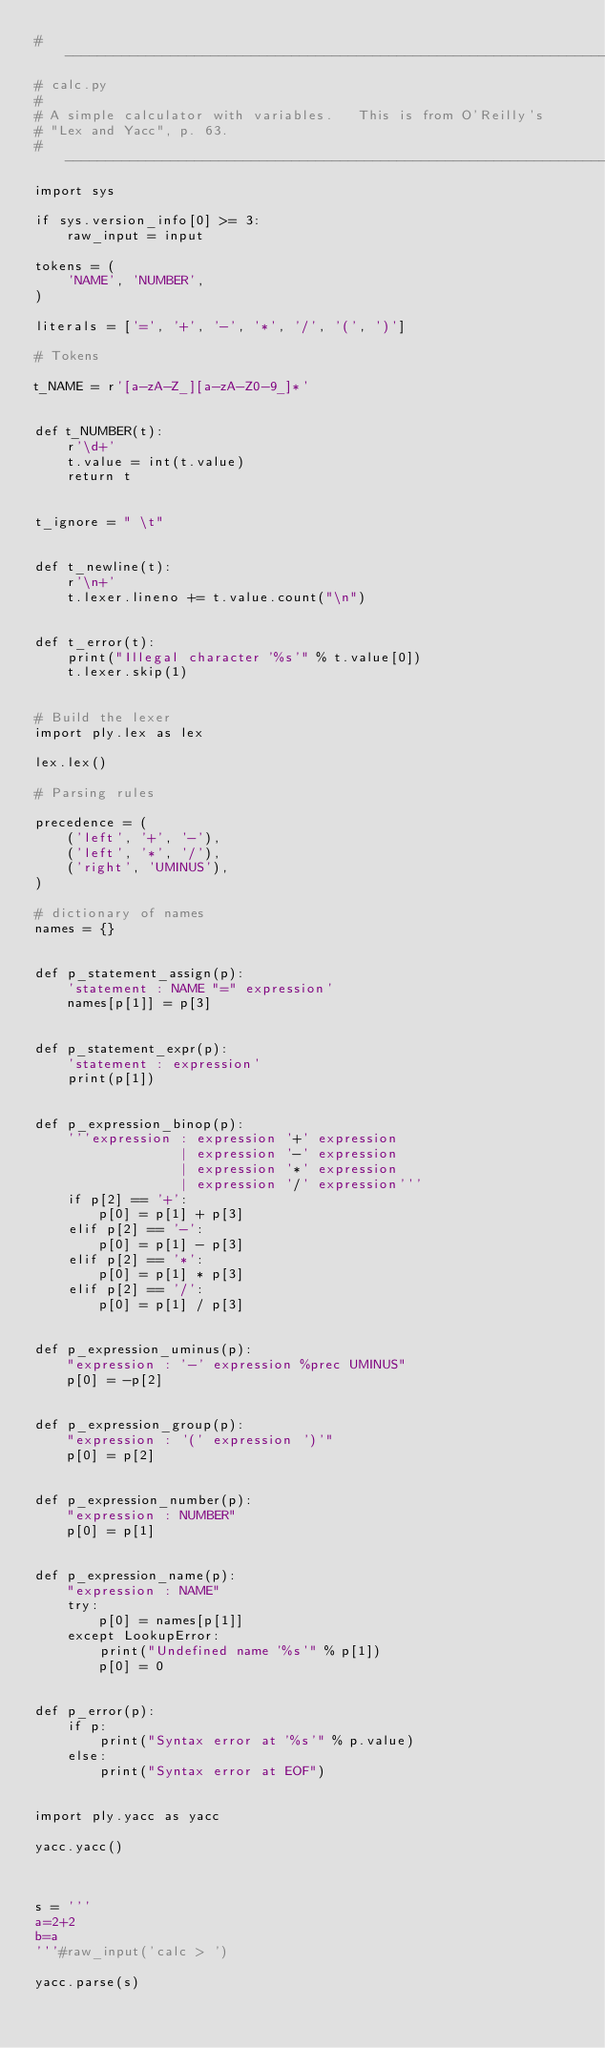<code> <loc_0><loc_0><loc_500><loc_500><_Python_># -----------------------------------------------------------------------------
# calc.py
#
# A simple calculator with variables.   This is from O'Reilly's
# "Lex and Yacc", p. 63.
# -----------------------------------------------------------------------------
import sys

if sys.version_info[0] >= 3:
    raw_input = input

tokens = (
    'NAME', 'NUMBER',
)

literals = ['=', '+', '-', '*', '/', '(', ')']

# Tokens

t_NAME = r'[a-zA-Z_][a-zA-Z0-9_]*'


def t_NUMBER(t):
    r'\d+'
    t.value = int(t.value)
    return t


t_ignore = " \t"


def t_newline(t):
    r'\n+'
    t.lexer.lineno += t.value.count("\n")


def t_error(t):
    print("Illegal character '%s'" % t.value[0])
    t.lexer.skip(1)


# Build the lexer
import ply.lex as lex

lex.lex()

# Parsing rules

precedence = (
    ('left', '+', '-'),
    ('left', '*', '/'),
    ('right', 'UMINUS'),
)

# dictionary of names
names = {}


def p_statement_assign(p):
    'statement : NAME "=" expression'
    names[p[1]] = p[3]


def p_statement_expr(p):
    'statement : expression'
    print(p[1])


def p_expression_binop(p):
    '''expression : expression '+' expression
                  | expression '-' expression
                  | expression '*' expression
                  | expression '/' expression'''
    if p[2] == '+':
        p[0] = p[1] + p[3]
    elif p[2] == '-':
        p[0] = p[1] - p[3]
    elif p[2] == '*':
        p[0] = p[1] * p[3]
    elif p[2] == '/':
        p[0] = p[1] / p[3]


def p_expression_uminus(p):
    "expression : '-' expression %prec UMINUS"
    p[0] = -p[2]


def p_expression_group(p):
    "expression : '(' expression ')'"
    p[0] = p[2]


def p_expression_number(p):
    "expression : NUMBER"
    p[0] = p[1]


def p_expression_name(p):
    "expression : NAME"
    try:
        p[0] = names[p[1]]
    except LookupError:
        print("Undefined name '%s'" % p[1])
        p[0] = 0


def p_error(p):
    if p:
        print("Syntax error at '%s'" % p.value)
    else:
        print("Syntax error at EOF")


import ply.yacc as yacc

yacc.yacc()



s = '''
a=2+2
b=a
'''#raw_input('calc > ')

yacc.parse(s)</code> 